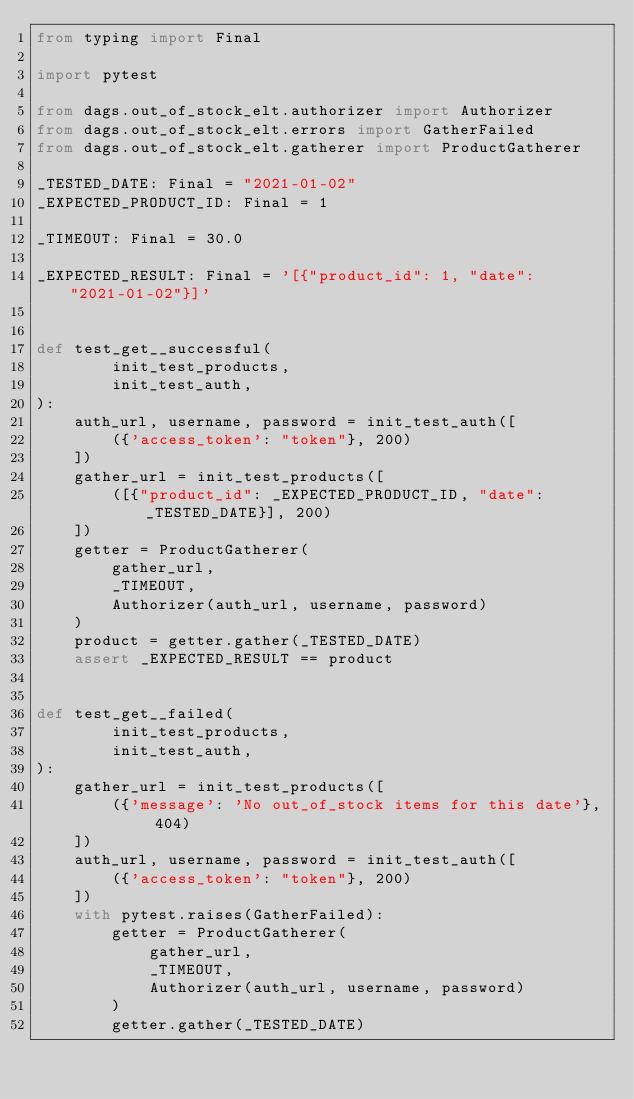Convert code to text. <code><loc_0><loc_0><loc_500><loc_500><_Python_>from typing import Final

import pytest

from dags.out_of_stock_elt.authorizer import Authorizer
from dags.out_of_stock_elt.errors import GatherFailed
from dags.out_of_stock_elt.gatherer import ProductGatherer

_TESTED_DATE: Final = "2021-01-02"
_EXPECTED_PRODUCT_ID: Final = 1

_TIMEOUT: Final = 30.0

_EXPECTED_RESULT: Final = '[{"product_id": 1, "date": "2021-01-02"}]'


def test_get__successful(
        init_test_products,
        init_test_auth,
):
    auth_url, username, password = init_test_auth([
        ({'access_token': "token"}, 200)
    ])
    gather_url = init_test_products([
        ([{"product_id": _EXPECTED_PRODUCT_ID, "date": _TESTED_DATE}], 200)
    ])
    getter = ProductGatherer(
        gather_url,
        _TIMEOUT,
        Authorizer(auth_url, username, password)
    )
    product = getter.gather(_TESTED_DATE)
    assert _EXPECTED_RESULT == product


def test_get__failed(
        init_test_products,
        init_test_auth,
):
    gather_url = init_test_products([
        ({'message': 'No out_of_stock items for this date'}, 404)
    ])
    auth_url, username, password = init_test_auth([
        ({'access_token': "token"}, 200)
    ])
    with pytest.raises(GatherFailed):
        getter = ProductGatherer(
            gather_url,
            _TIMEOUT,
            Authorizer(auth_url, username, password)
        )
        getter.gather(_TESTED_DATE)
</code> 